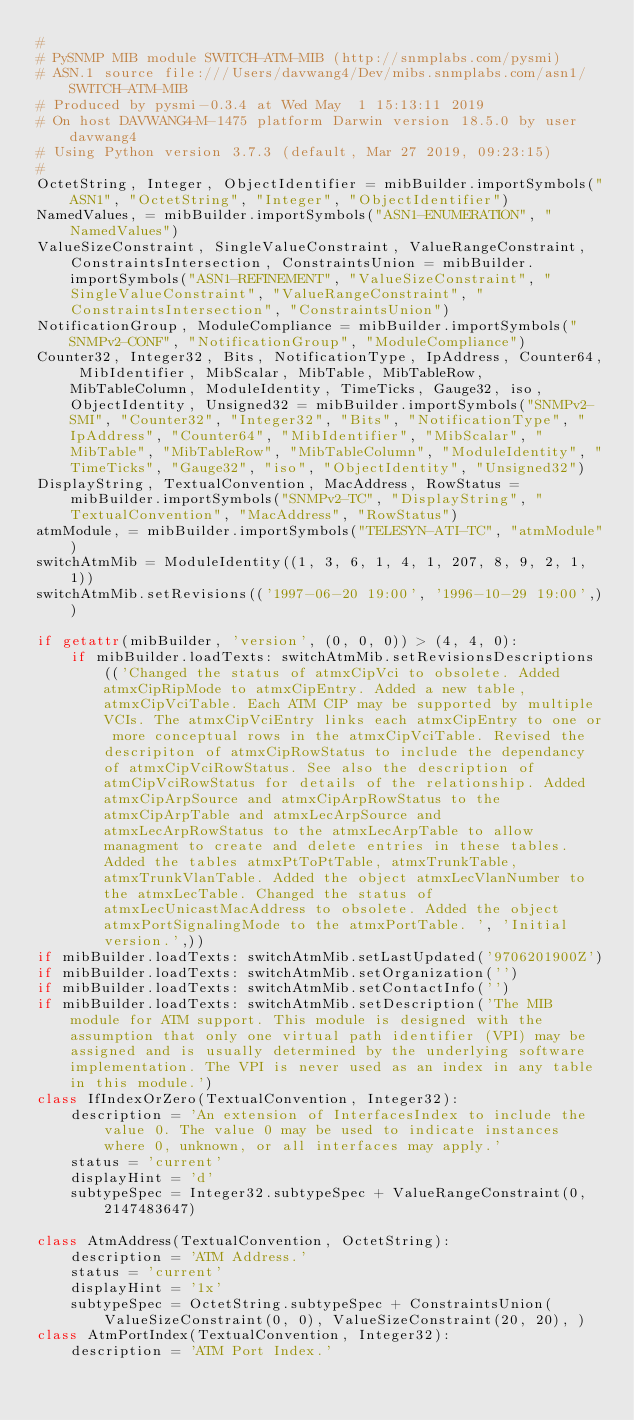<code> <loc_0><loc_0><loc_500><loc_500><_Python_>#
# PySNMP MIB module SWITCH-ATM-MIB (http://snmplabs.com/pysmi)
# ASN.1 source file:///Users/davwang4/Dev/mibs.snmplabs.com/asn1/SWITCH-ATM-MIB
# Produced by pysmi-0.3.4 at Wed May  1 15:13:11 2019
# On host DAVWANG4-M-1475 platform Darwin version 18.5.0 by user davwang4
# Using Python version 3.7.3 (default, Mar 27 2019, 09:23:15) 
#
OctetString, Integer, ObjectIdentifier = mibBuilder.importSymbols("ASN1", "OctetString", "Integer", "ObjectIdentifier")
NamedValues, = mibBuilder.importSymbols("ASN1-ENUMERATION", "NamedValues")
ValueSizeConstraint, SingleValueConstraint, ValueRangeConstraint, ConstraintsIntersection, ConstraintsUnion = mibBuilder.importSymbols("ASN1-REFINEMENT", "ValueSizeConstraint", "SingleValueConstraint", "ValueRangeConstraint", "ConstraintsIntersection", "ConstraintsUnion")
NotificationGroup, ModuleCompliance = mibBuilder.importSymbols("SNMPv2-CONF", "NotificationGroup", "ModuleCompliance")
Counter32, Integer32, Bits, NotificationType, IpAddress, Counter64, MibIdentifier, MibScalar, MibTable, MibTableRow, MibTableColumn, ModuleIdentity, TimeTicks, Gauge32, iso, ObjectIdentity, Unsigned32 = mibBuilder.importSymbols("SNMPv2-SMI", "Counter32", "Integer32", "Bits", "NotificationType", "IpAddress", "Counter64", "MibIdentifier", "MibScalar", "MibTable", "MibTableRow", "MibTableColumn", "ModuleIdentity", "TimeTicks", "Gauge32", "iso", "ObjectIdentity", "Unsigned32")
DisplayString, TextualConvention, MacAddress, RowStatus = mibBuilder.importSymbols("SNMPv2-TC", "DisplayString", "TextualConvention", "MacAddress", "RowStatus")
atmModule, = mibBuilder.importSymbols("TELESYN-ATI-TC", "atmModule")
switchAtmMib = ModuleIdentity((1, 3, 6, 1, 4, 1, 207, 8, 9, 2, 1, 1))
switchAtmMib.setRevisions(('1997-06-20 19:00', '1996-10-29 19:00',))

if getattr(mibBuilder, 'version', (0, 0, 0)) > (4, 4, 0):
    if mibBuilder.loadTexts: switchAtmMib.setRevisionsDescriptions(('Changed the status of atmxCipVci to obsolete. Added atmxCipRipMode to atmxCipEntry. Added a new table, atmxCipVciTable. Each ATM CIP may be supported by multiple VCIs. The atmxCipVciEntry links each atmxCipEntry to one or more conceptual rows in the atmxCipVciTable. Revised the descripiton of atmxCipRowStatus to include the dependancy of atmxCipVciRowStatus. See also the description of atmCipVciRowStatus for details of the relationship. Added atmxCipArpSource and atmxCipArpRowStatus to the atmxCipArpTable and atmxLecArpSource and atmxLecArpRowStatus to the atmxLecArpTable to allow managment to create and delete entries in these tables. Added the tables atmxPtToPtTable, atmxTrunkTable, atmxTrunkVlanTable. Added the object atmxLecVlanNumber to the atmxLecTable. Changed the status of atmxLecUnicastMacAddress to obsolete. Added the object atmxPortSignalingMode to the atmxPortTable. ', 'Initial version.',))
if mibBuilder.loadTexts: switchAtmMib.setLastUpdated('9706201900Z')
if mibBuilder.loadTexts: switchAtmMib.setOrganization('')
if mibBuilder.loadTexts: switchAtmMib.setContactInfo('')
if mibBuilder.loadTexts: switchAtmMib.setDescription('The MIB module for ATM support. This module is designed with the assumption that only one virtual path identifier (VPI) may be assigned and is usually determined by the underlying software implementation. The VPI is never used as an index in any table in this module.')
class IfIndexOrZero(TextualConvention, Integer32):
    description = 'An extension of InterfacesIndex to include the value 0. The value 0 may be used to indicate instances where 0, unknown, or all interfaces may apply.'
    status = 'current'
    displayHint = 'd'
    subtypeSpec = Integer32.subtypeSpec + ValueRangeConstraint(0, 2147483647)

class AtmAddress(TextualConvention, OctetString):
    description = 'ATM Address.'
    status = 'current'
    displayHint = '1x'
    subtypeSpec = OctetString.subtypeSpec + ConstraintsUnion(ValueSizeConstraint(0, 0), ValueSizeConstraint(20, 20), )
class AtmPortIndex(TextualConvention, Integer32):
    description = 'ATM Port Index.'</code> 